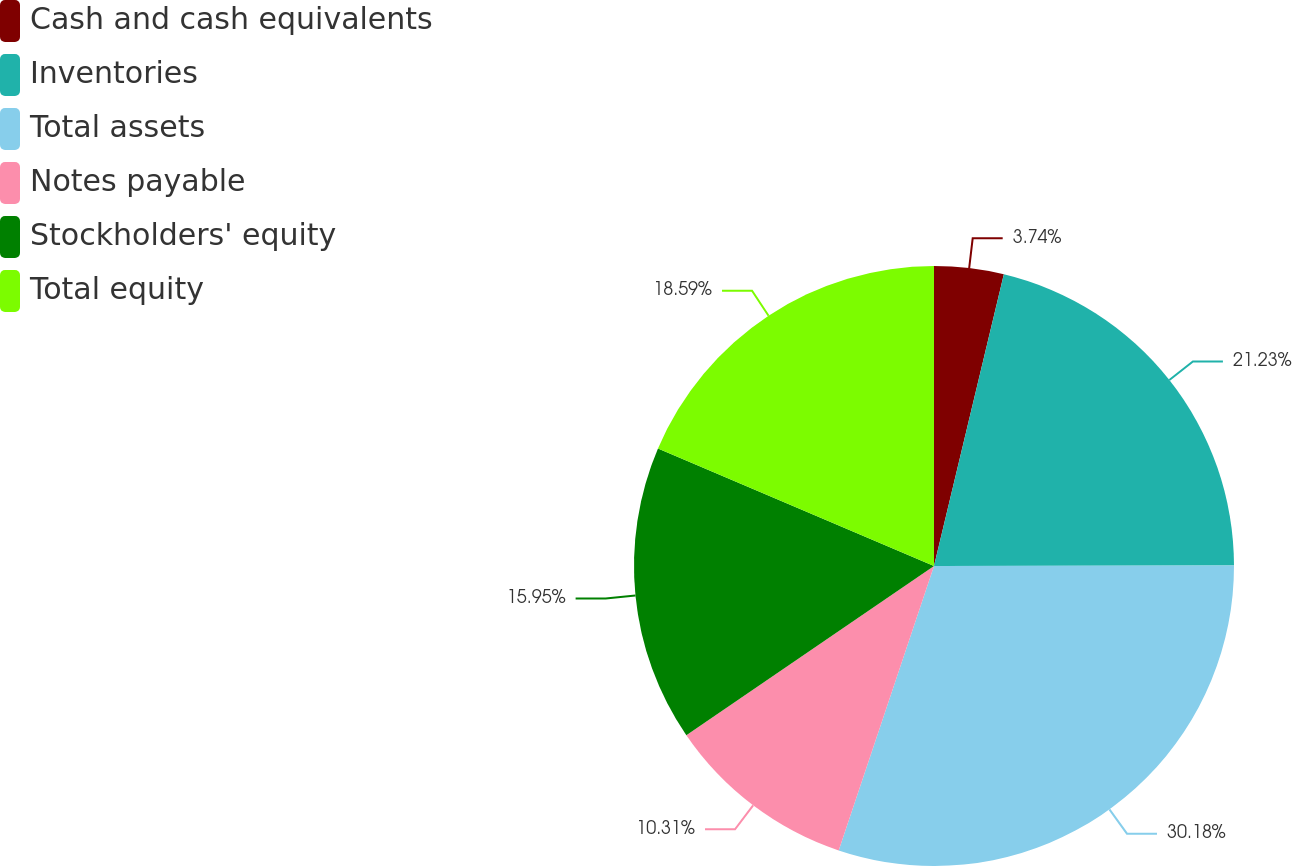Convert chart to OTSL. <chart><loc_0><loc_0><loc_500><loc_500><pie_chart><fcel>Cash and cash equivalents<fcel>Inventories<fcel>Total assets<fcel>Notes payable<fcel>Stockholders' equity<fcel>Total equity<nl><fcel>3.74%<fcel>21.23%<fcel>30.17%<fcel>10.31%<fcel>15.95%<fcel>18.59%<nl></chart> 